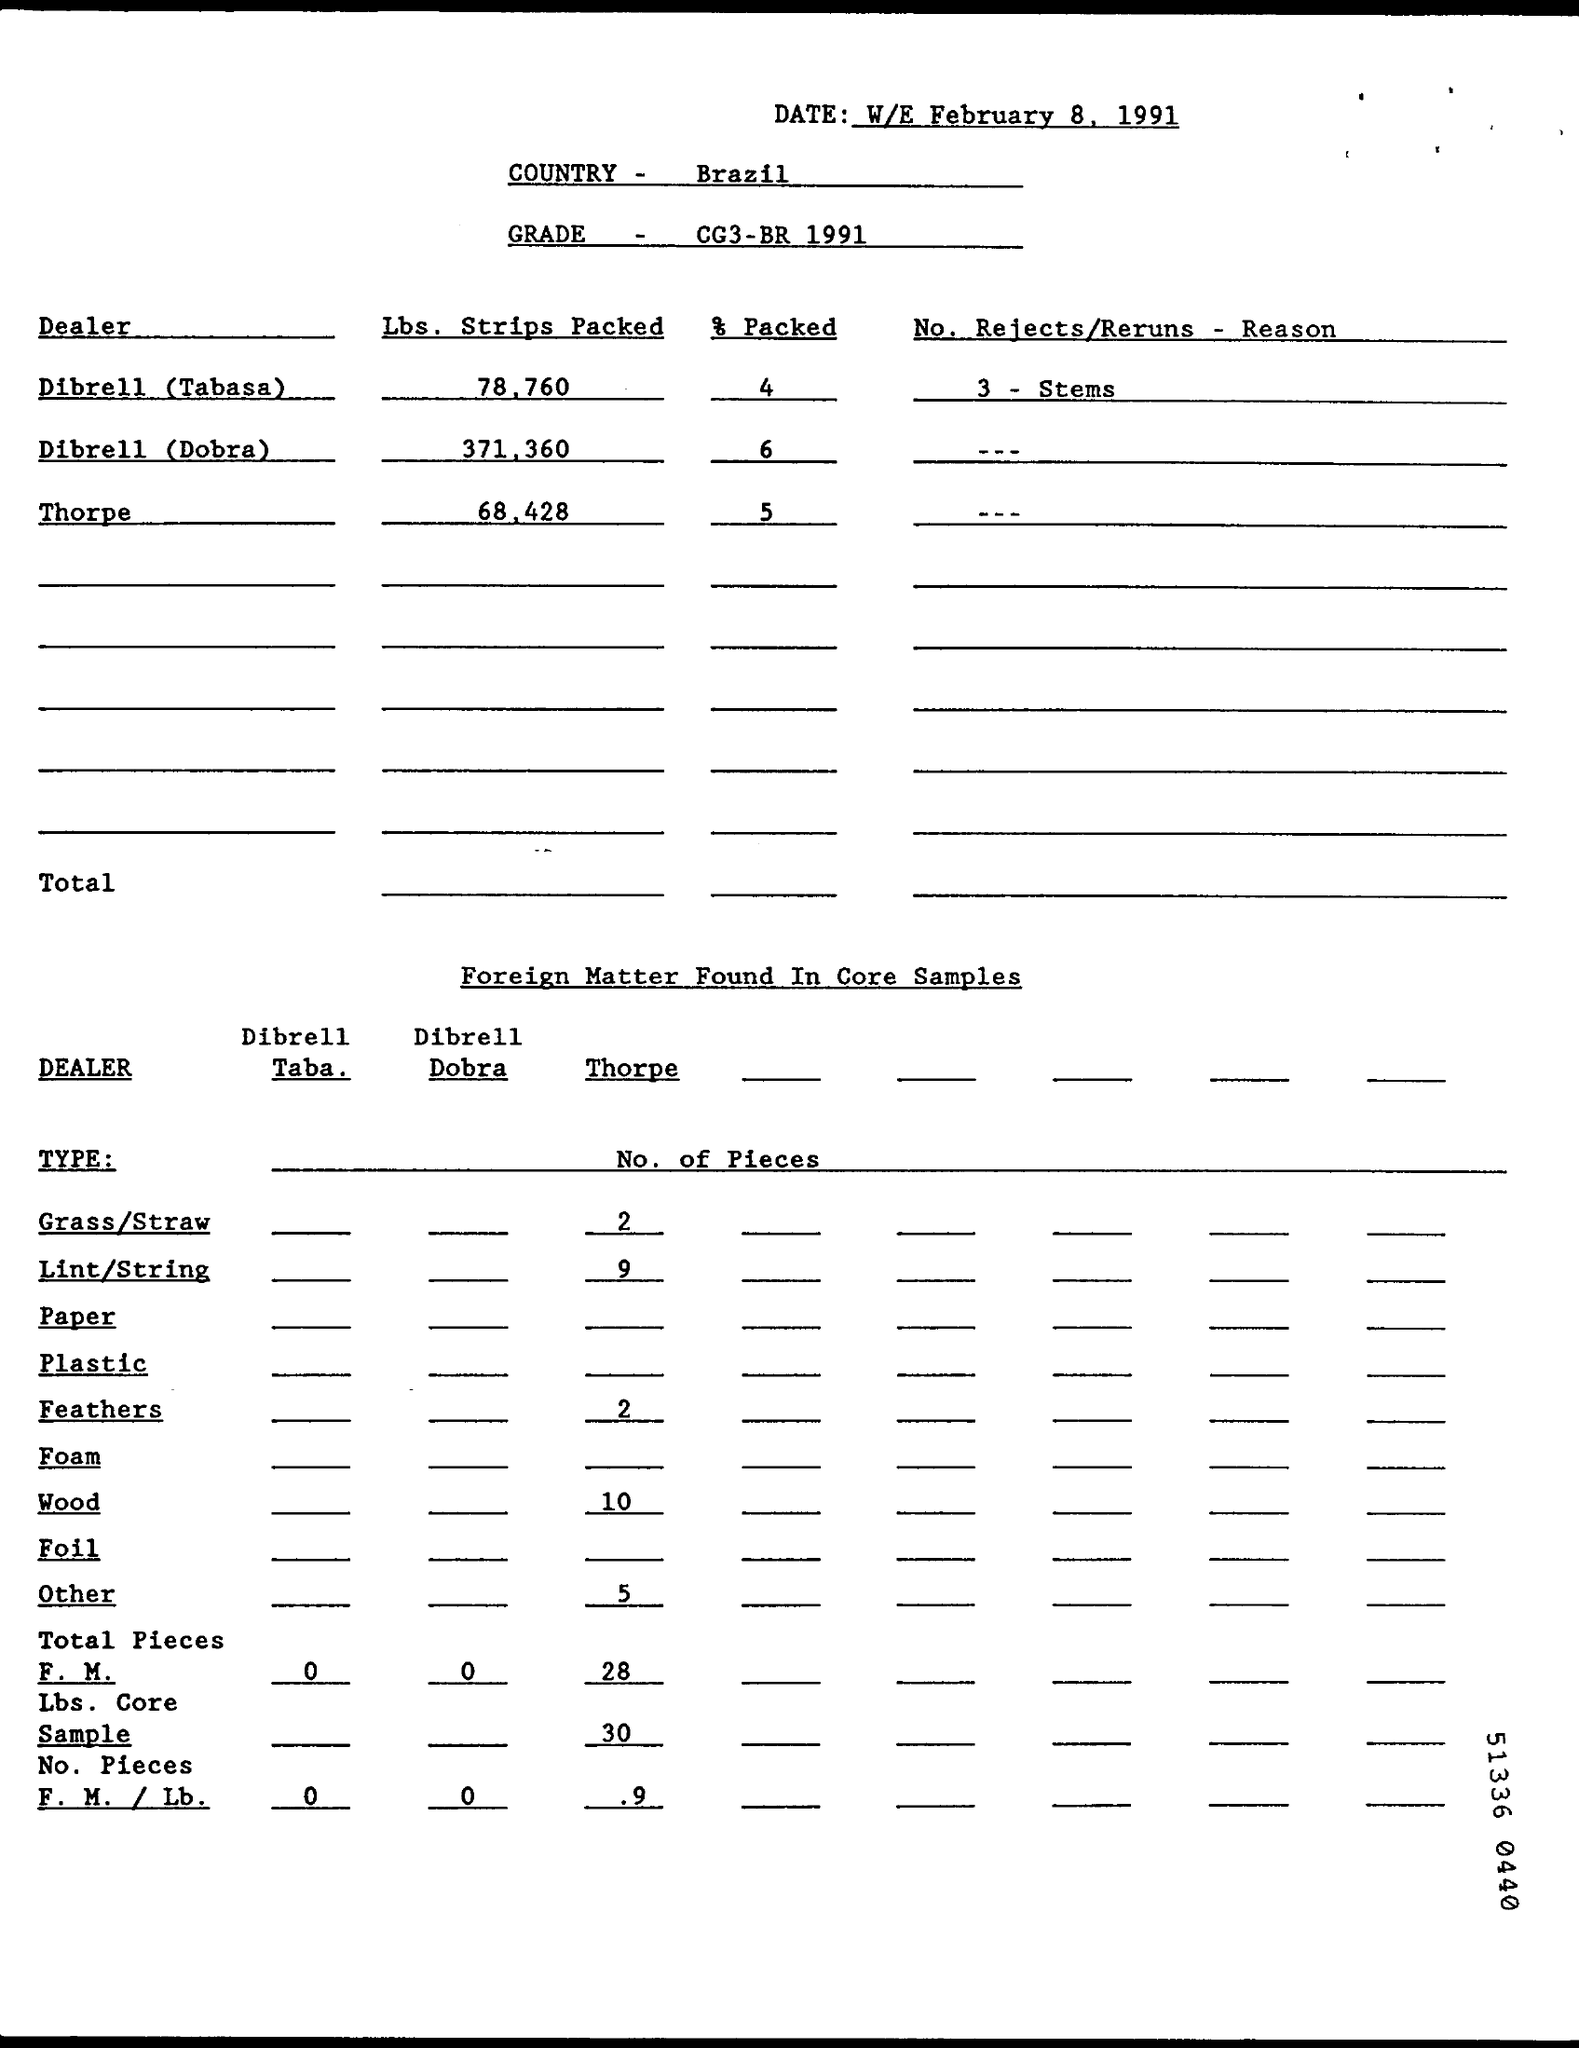Which country is mentioned?
Your response must be concise. Brazil. What is the grade specified?
Provide a short and direct response. CG3 - BR 1991. What percentage was packed by Dibrell (Dobra)?
Give a very brief answer. 6. How many Rejects/ Reruns from Dibrell (Tabasa)?
Your answer should be compact. 3 - Stems. How many pieces of lint/string were found from Thorpe?
Offer a terse response. 9. 